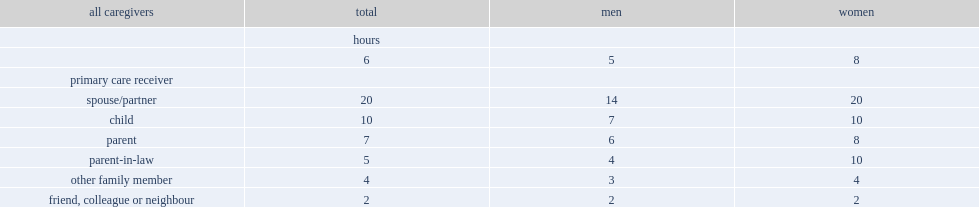How many hours did senior caregivers spend per week providing care or support to family and friends in 2018? 6.0. How many hours did senior men spend per week providing care or support to family and friends in 2018? 5.0. How many hours did senior women spend per week providing care or support to family and friends in 2018? 8.0. Which activity had the lowest number of weekly hours spent on caregiving involved? Friend, colleague or neighbour. Which caregiver did seniors spend the most hours on? Spouse/partner. How many hours per week did senior women spend on caring for a spouse? 20.0. How many hours per week did senior men spend on caring for a spouse? 14.0. Which sex spent more hours on caring for a child? Women. 